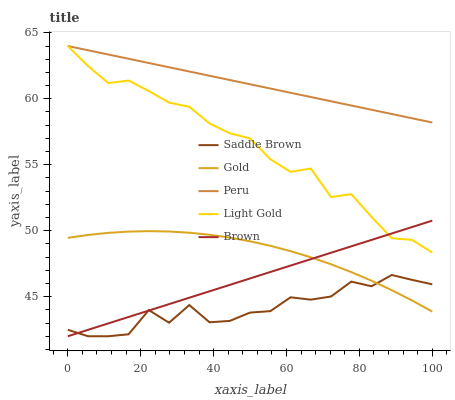Does Saddle Brown have the minimum area under the curve?
Answer yes or no. Yes. Does Peru have the maximum area under the curve?
Answer yes or no. Yes. Does Light Gold have the minimum area under the curve?
Answer yes or no. No. Does Light Gold have the maximum area under the curve?
Answer yes or no. No. Is Brown the smoothest?
Answer yes or no. Yes. Is Saddle Brown the roughest?
Answer yes or no. Yes. Is Light Gold the smoothest?
Answer yes or no. No. Is Light Gold the roughest?
Answer yes or no. No. Does Saddle Brown have the lowest value?
Answer yes or no. Yes. Does Light Gold have the lowest value?
Answer yes or no. No. Does Light Gold have the highest value?
Answer yes or no. Yes. Does Saddle Brown have the highest value?
Answer yes or no. No. Is Saddle Brown less than Peru?
Answer yes or no. Yes. Is Light Gold greater than Gold?
Answer yes or no. Yes. Does Peru intersect Light Gold?
Answer yes or no. Yes. Is Peru less than Light Gold?
Answer yes or no. No. Is Peru greater than Light Gold?
Answer yes or no. No. Does Saddle Brown intersect Peru?
Answer yes or no. No. 